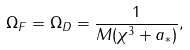<formula> <loc_0><loc_0><loc_500><loc_500>\Omega _ { F } = \Omega _ { D } = \frac { 1 } { M ( \chi ^ { 3 } + a _ { * } ) } , \\</formula> 